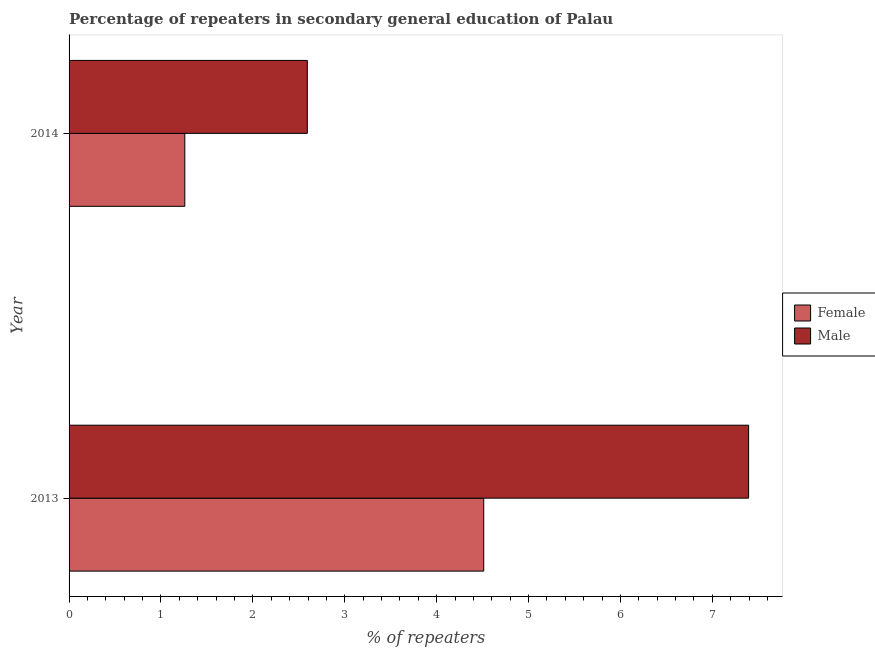How many different coloured bars are there?
Provide a short and direct response. 2. How many groups of bars are there?
Your answer should be compact. 2. How many bars are there on the 2nd tick from the top?
Your answer should be compact. 2. What is the label of the 1st group of bars from the top?
Your response must be concise. 2014. What is the percentage of female repeaters in 2013?
Make the answer very short. 4.51. Across all years, what is the maximum percentage of male repeaters?
Offer a very short reply. 7.39. Across all years, what is the minimum percentage of female repeaters?
Provide a succinct answer. 1.26. In which year was the percentage of female repeaters maximum?
Your response must be concise. 2013. What is the total percentage of male repeaters in the graph?
Your answer should be compact. 9.99. What is the difference between the percentage of female repeaters in 2013 and that in 2014?
Ensure brevity in your answer.  3.25. What is the difference between the percentage of female repeaters in 2014 and the percentage of male repeaters in 2013?
Give a very brief answer. -6.13. What is the average percentage of male repeaters per year?
Give a very brief answer. 4.99. In the year 2013, what is the difference between the percentage of female repeaters and percentage of male repeaters?
Your answer should be very brief. -2.88. In how many years, is the percentage of female repeaters greater than 7.4 %?
Ensure brevity in your answer.  0. What is the ratio of the percentage of female repeaters in 2013 to that in 2014?
Make the answer very short. 3.58. Is the difference between the percentage of female repeaters in 2013 and 2014 greater than the difference between the percentage of male repeaters in 2013 and 2014?
Your response must be concise. No. In how many years, is the percentage of male repeaters greater than the average percentage of male repeaters taken over all years?
Your answer should be very brief. 1. How many bars are there?
Offer a very short reply. 4. Does the graph contain grids?
Give a very brief answer. No. How many legend labels are there?
Your answer should be very brief. 2. How are the legend labels stacked?
Offer a very short reply. Vertical. What is the title of the graph?
Your response must be concise. Percentage of repeaters in secondary general education of Palau. Does "Frequency of shipment arrival" appear as one of the legend labels in the graph?
Offer a terse response. No. What is the label or title of the X-axis?
Make the answer very short. % of repeaters. What is the label or title of the Y-axis?
Provide a succinct answer. Year. What is the % of repeaters of Female in 2013?
Your answer should be compact. 4.51. What is the % of repeaters in Male in 2013?
Offer a terse response. 7.39. What is the % of repeaters in Female in 2014?
Your answer should be very brief. 1.26. What is the % of repeaters of Male in 2014?
Your answer should be compact. 2.59. Across all years, what is the maximum % of repeaters of Female?
Your answer should be compact. 4.51. Across all years, what is the maximum % of repeaters in Male?
Your answer should be compact. 7.39. Across all years, what is the minimum % of repeaters of Female?
Your answer should be very brief. 1.26. Across all years, what is the minimum % of repeaters in Male?
Your response must be concise. 2.59. What is the total % of repeaters in Female in the graph?
Your answer should be very brief. 5.77. What is the total % of repeaters in Male in the graph?
Ensure brevity in your answer.  9.99. What is the difference between the % of repeaters of Female in 2013 and that in 2014?
Provide a short and direct response. 3.25. What is the difference between the % of repeaters in Male in 2013 and that in 2014?
Offer a terse response. 4.8. What is the difference between the % of repeaters in Female in 2013 and the % of repeaters in Male in 2014?
Make the answer very short. 1.92. What is the average % of repeaters in Female per year?
Your response must be concise. 2.89. What is the average % of repeaters in Male per year?
Ensure brevity in your answer.  4.99. In the year 2013, what is the difference between the % of repeaters in Female and % of repeaters in Male?
Keep it short and to the point. -2.88. In the year 2014, what is the difference between the % of repeaters in Female and % of repeaters in Male?
Provide a short and direct response. -1.33. What is the ratio of the % of repeaters of Female in 2013 to that in 2014?
Your answer should be very brief. 3.58. What is the ratio of the % of repeaters of Male in 2013 to that in 2014?
Your response must be concise. 2.85. What is the difference between the highest and the second highest % of repeaters of Female?
Offer a very short reply. 3.25. What is the difference between the highest and the second highest % of repeaters of Male?
Your answer should be very brief. 4.8. What is the difference between the highest and the lowest % of repeaters in Female?
Make the answer very short. 3.25. What is the difference between the highest and the lowest % of repeaters in Male?
Provide a succinct answer. 4.8. 